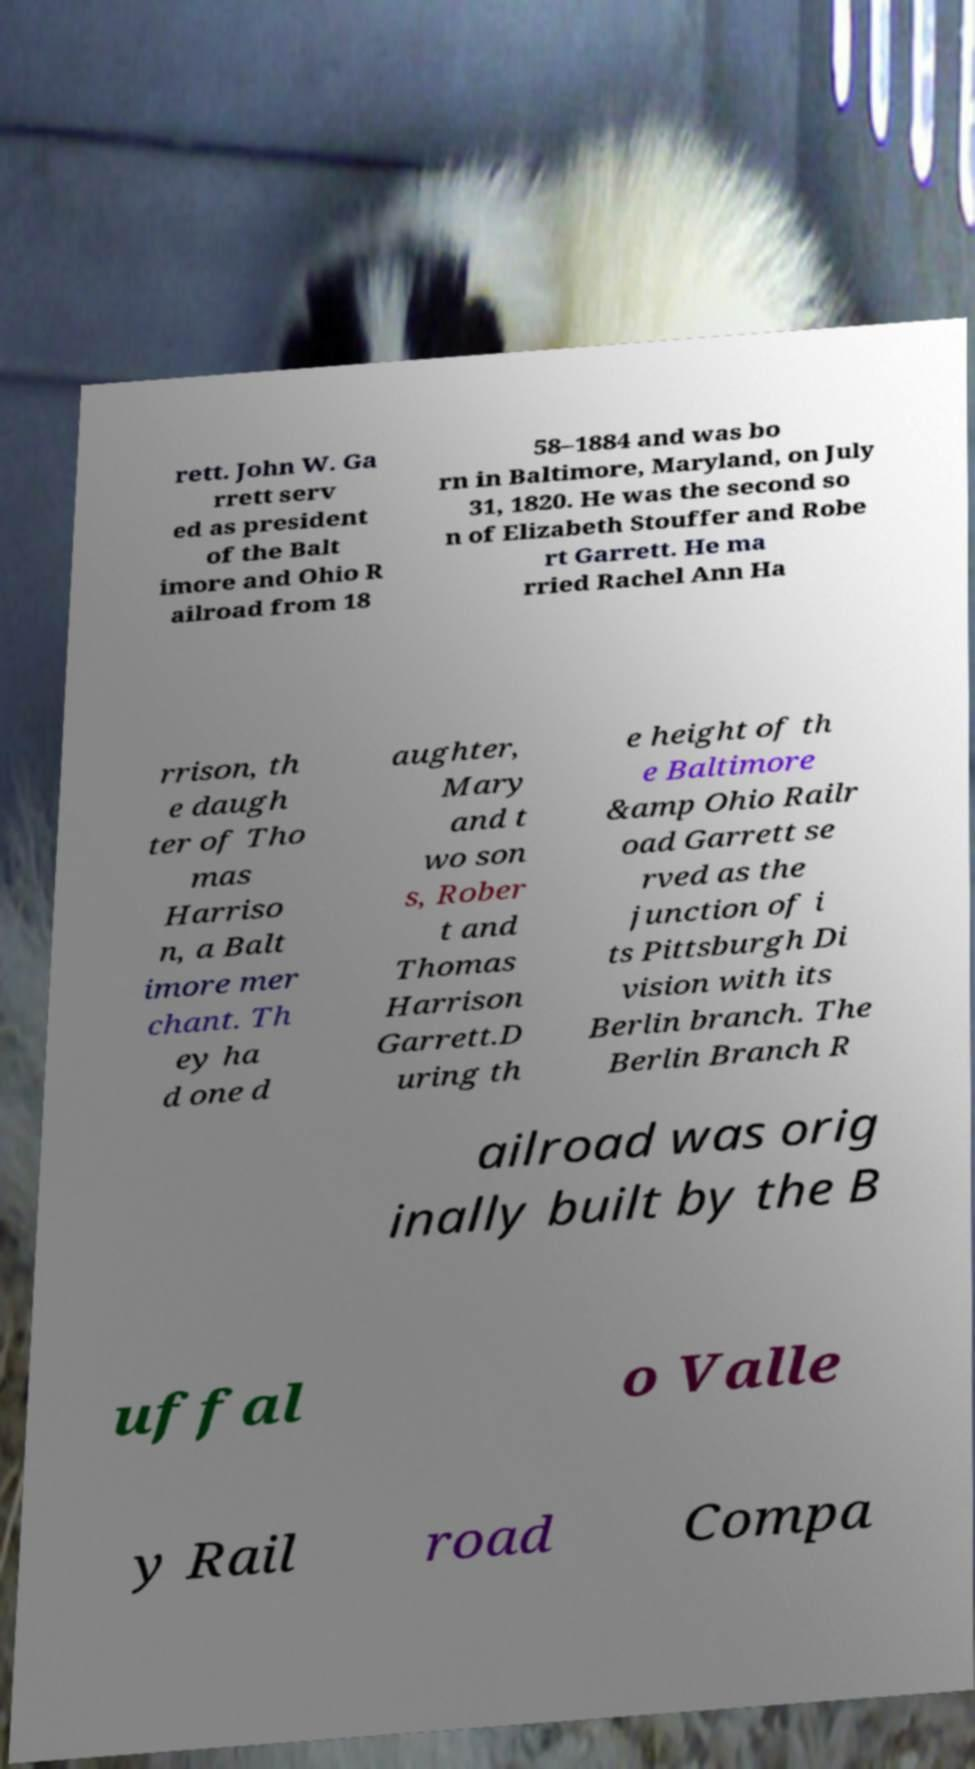For documentation purposes, I need the text within this image transcribed. Could you provide that? rett. John W. Ga rrett serv ed as president of the Balt imore and Ohio R ailroad from 18 58–1884 and was bo rn in Baltimore, Maryland, on July 31, 1820. He was the second so n of Elizabeth Stouffer and Robe rt Garrett. He ma rried Rachel Ann Ha rrison, th e daugh ter of Tho mas Harriso n, a Balt imore mer chant. Th ey ha d one d aughter, Mary and t wo son s, Rober t and Thomas Harrison Garrett.D uring th e height of th e Baltimore &amp Ohio Railr oad Garrett se rved as the junction of i ts Pittsburgh Di vision with its Berlin branch. The Berlin Branch R ailroad was orig inally built by the B uffal o Valle y Rail road Compa 